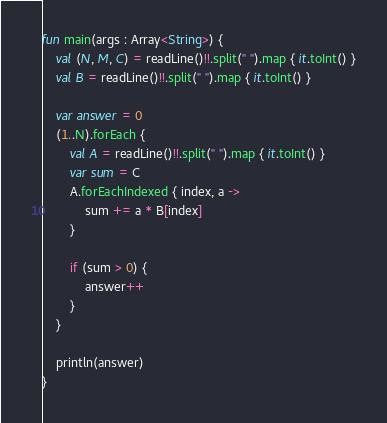<code> <loc_0><loc_0><loc_500><loc_500><_Kotlin_>fun main(args : Array<String>) {
    val (N, M, C) = readLine()!!.split(" ").map { it.toInt() }
    val B = readLine()!!.split(" ").map { it.toInt() }

    var answer = 0
    (1..N).forEach {
        val A = readLine()!!.split(" ").map { it.toInt() }
        var sum = C
        A.forEachIndexed { index, a ->
            sum += a * B[index]
        }

        if (sum > 0) {
            answer++
        }
    }

    println(answer)
}</code> 